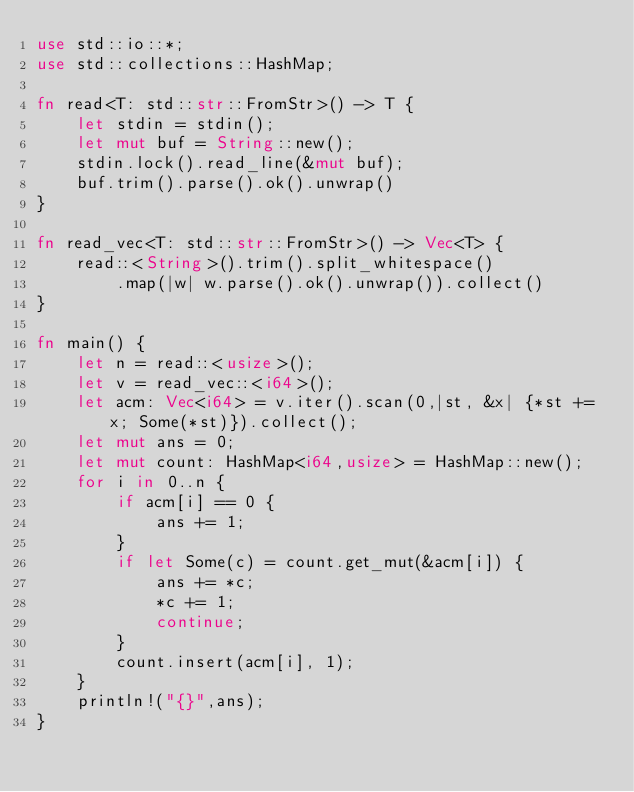<code> <loc_0><loc_0><loc_500><loc_500><_Rust_>use std::io::*;
use std::collections::HashMap;

fn read<T: std::str::FromStr>() -> T {
    let stdin = stdin();
    let mut buf = String::new();
	stdin.lock().read_line(&mut buf);
	buf.trim().parse().ok().unwrap()
}

fn read_vec<T: std::str::FromStr>() -> Vec<T> {
	read::<String>().trim().split_whitespace()
        .map(|w| w.parse().ok().unwrap()).collect()
}

fn main() {
    let n = read::<usize>();
    let v = read_vec::<i64>();
    let acm: Vec<i64> = v.iter().scan(0,|st, &x| {*st += x; Some(*st)}).collect();
    let mut ans = 0;
    let mut count: HashMap<i64,usize> = HashMap::new();
    for i in 0..n {
        if acm[i] == 0 {
            ans += 1;
        }
        if let Some(c) = count.get_mut(&acm[i]) {
            ans += *c;
            *c += 1;
            continue;
        }
        count.insert(acm[i], 1);
    }
    println!("{}",ans);
}
</code> 